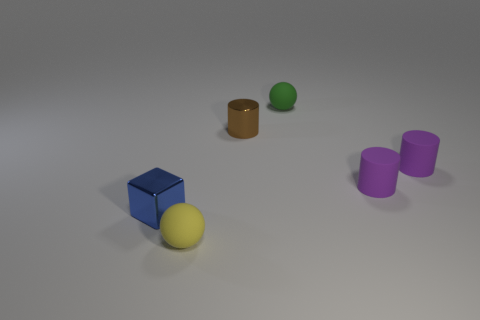Is the tiny cube made of the same material as the small cylinder that is left of the small green sphere?
Ensure brevity in your answer.  Yes. There is a metallic object that is right of the matte sphere in front of the small green rubber sphere; what size is it?
Your answer should be compact. Small. Are there any other things that are the same color as the shiny cube?
Your answer should be compact. No. Does the small sphere in front of the tiny green thing have the same material as the sphere behind the tiny block?
Your answer should be very brief. Yes. What is the material of the thing that is both to the right of the blue block and left of the tiny brown metallic thing?
Provide a short and direct response. Rubber. There is a tiny brown object; is its shape the same as the tiny rubber object that is left of the tiny green matte ball?
Ensure brevity in your answer.  No. What material is the tiny object behind the brown metallic cylinder that is on the right side of the tiny yellow rubber object left of the green matte thing made of?
Provide a succinct answer. Rubber. How many other objects are there of the same size as the brown cylinder?
Your answer should be very brief. 5. Is the small metal cylinder the same color as the small metallic block?
Your response must be concise. No. What number of matte things are in front of the green ball behind the metal thing that is left of the small yellow object?
Your answer should be very brief. 3. 